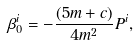Convert formula to latex. <formula><loc_0><loc_0><loc_500><loc_500>\beta ^ { i } _ { 0 } = - \frac { ( 5 m + c ) } { 4 m ^ { 2 } } P ^ { i } ,</formula> 